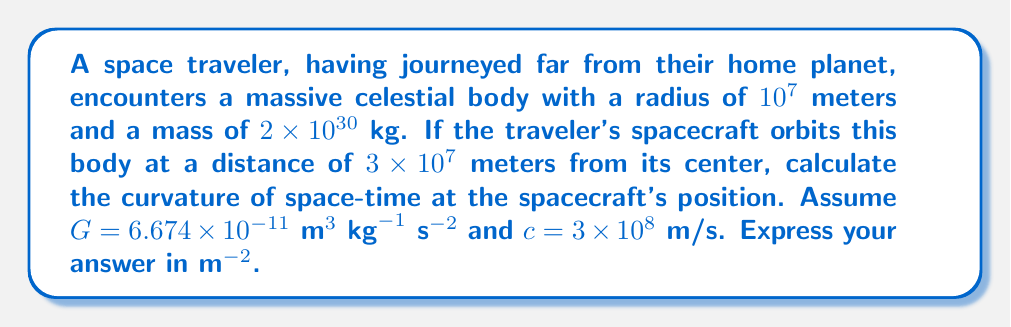Help me with this question. To solve this problem, we'll use the concept of space-time curvature in general relativity. The steps are as follows:

1) In general relativity, the curvature of space-time near a massive body is given by the Kretschmann scalar $K$, which for a Schwarzschild metric is:

   $$K = \frac{48G^2M^2}{c^4r^6}$$

   Where:
   $G$ is the gravitational constant
   $M$ is the mass of the celestial body
   $c$ is the speed of light
   $r$ is the distance from the center of the body

2) We're given:
   $G = 6.674 \times 10^{-11} \text{ m}^3 \text{ kg}^{-1} \text{ s}^{-2}$
   $M = 2 \times 10^{30} \text{ kg}$
   $c = 3 \times 10^8 \text{ m/s}$
   $r = 3 \times 10^7 \text{ m}$

3) Let's substitute these values into the equation:

   $$K = \frac{48(6.674 \times 10^{-11})^2(2 \times 10^{30})^2}{(3 \times 10^8)^4(3 \times 10^7)^6}$$

4) Simplify:
   $$K = \frac{48 \times (4.4542 \times 10^{-21}) \times (4 \times 10^{60})}{(8.1 \times 10^{32}) \times (7.29 \times 10^{42})}$$

   $$K = \frac{8.5520 \times 10^{41}}{5.9049 \times 10^{75}}$$

5) Calculate the final result:
   $$K \approx 1.4483 \times 10^{-34} \text{ m}^{-2}$$

This value represents the curvature of space-time at the spacecraft's position, quantifying how much the massive celestial body warps the fabric of space-time around it.
Answer: $1.4483 \times 10^{-34} \text{ m}^{-2}$ 